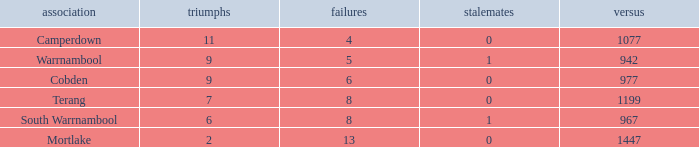How many wins did Cobden have when draws were more than 0? 0.0. 